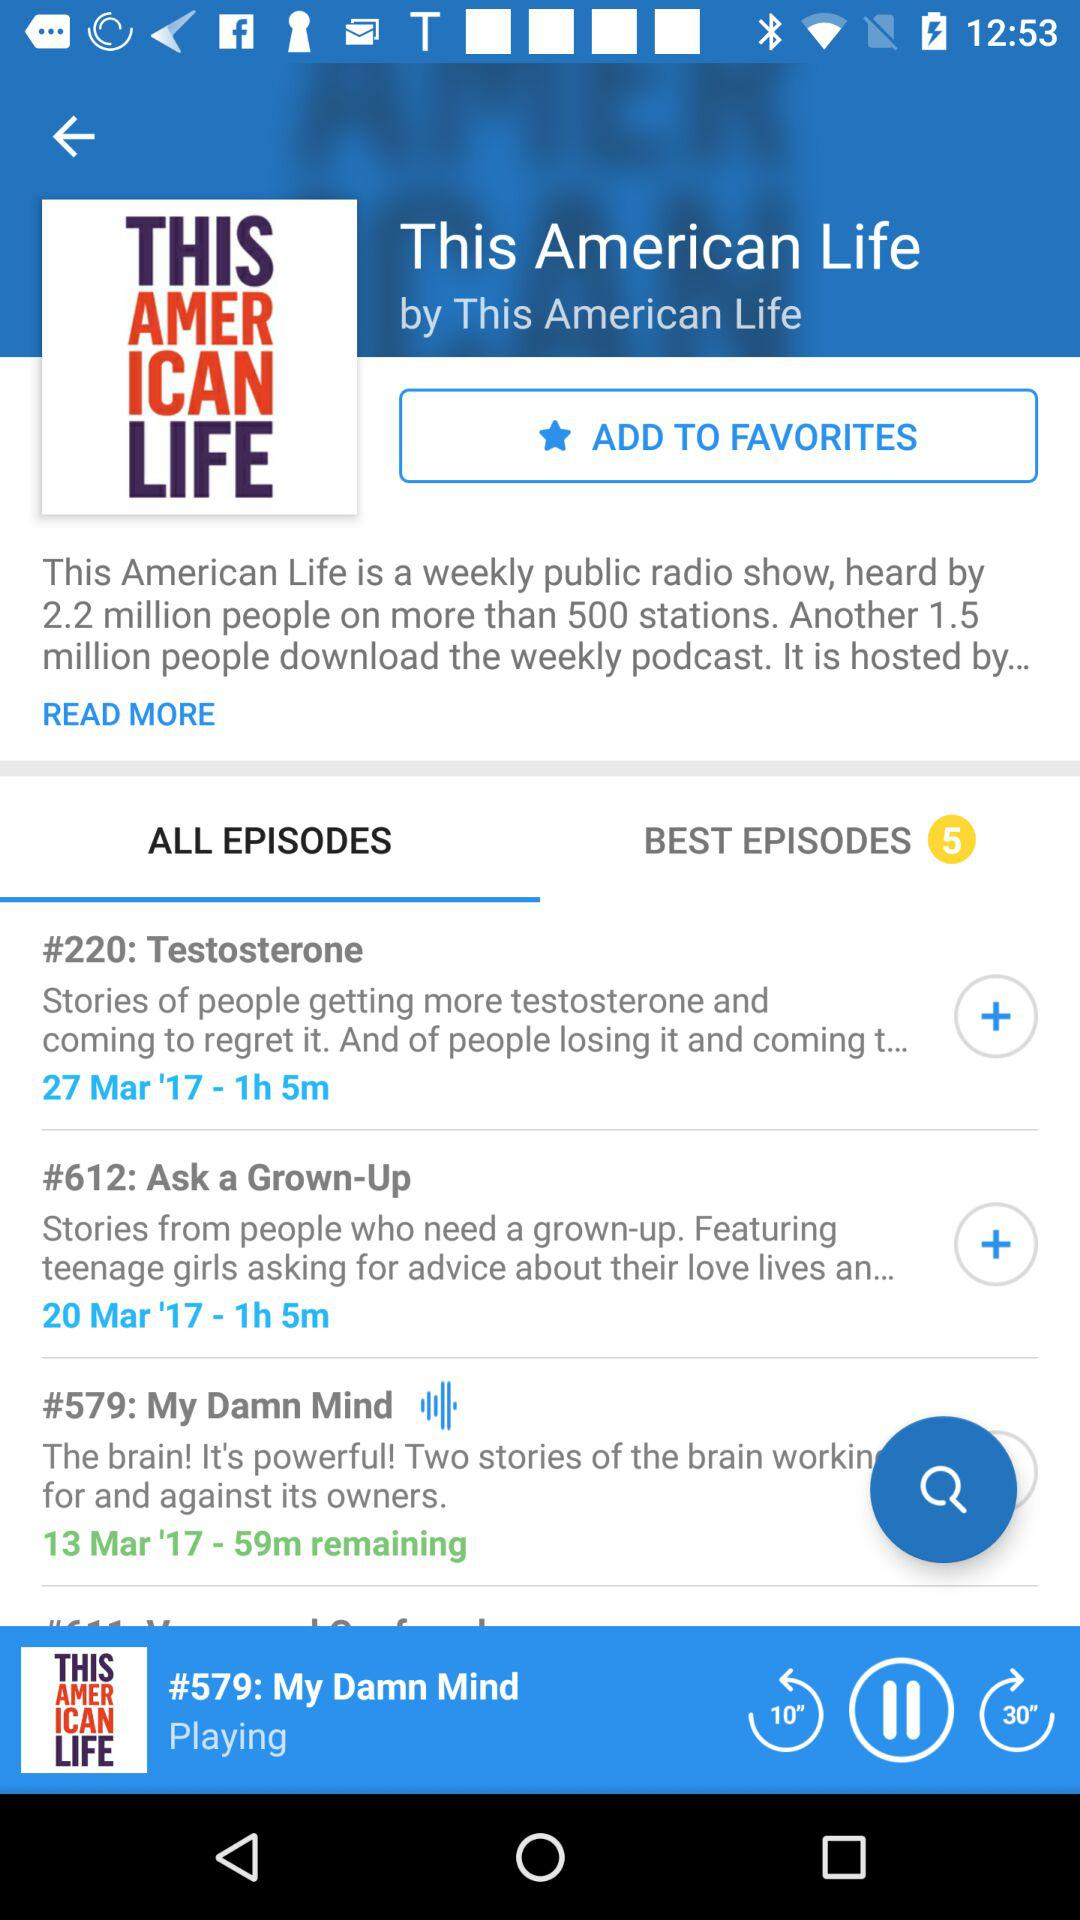How much time remains for the currently playing episode? The remaining time for the currently playing episode is 59 minutes. 